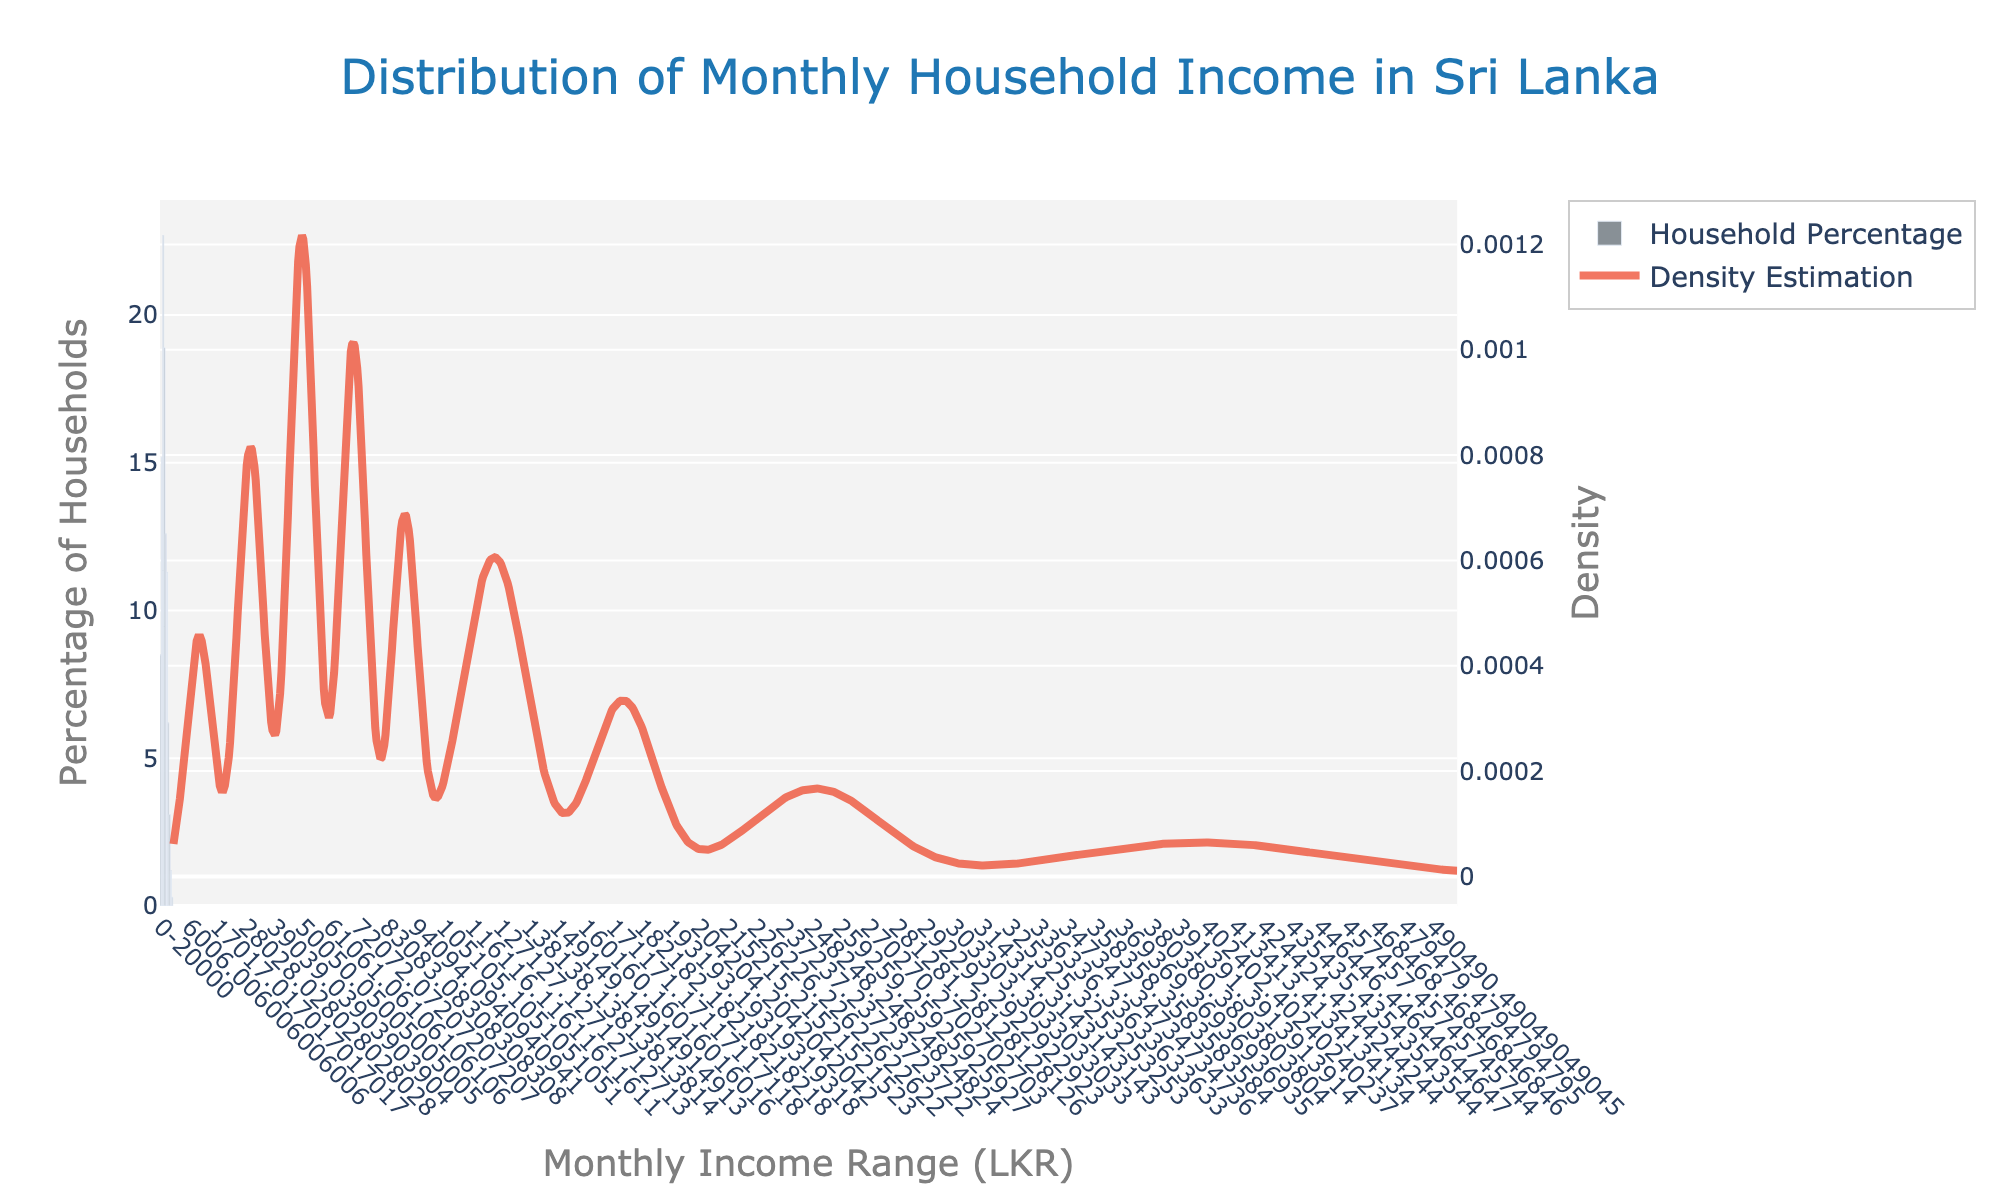What is the title of the figure? The title is located at the top center of the plot and reads "Distribution of Monthly Household Income in Sri Lanka".
Answer: Distribution of Monthly Household Income in Sri Lanka What is the income range with the highest percentage of households? By looking at the height of the bars, the tallest bar is for the income range "40001-60000", which indicates the highest percentage of households.
Answer: 40001-60000 Which income range has the lowest percentage of households, and what is its percentage? The smallest bar corresponds to the "500001+" income range, with a height denoting 0.3%.
Answer: 500001+, 0.3% How does the "100001-150000" income range compare to the "60001-80000" range in terms of household percentage? By comparing the heights of the bars, the "100001-150000" range (11.3%) is lower than the "60001-80000" range (18.9%).
Answer: 100001-150000 is lower than 60001-80000 Between which income ranges is most of the population concentrated? Observing the highest bars, most of the households fall between "20001-40000", "40001-60000", and "60001-80000".
Answer: 20001-80000 What is the shape of the density estimation curve around the "40001-60000" income range? The KDE peak near the "40001-60000" indicates a high density of households within this range, showing a peak in the curve.
Answer: Peak How many income ranges have a household percentage below 10%? Examine the bars below the 10% mark: "0-20000", "150001-200000", "200001-300000", "300001-500000", and "500001+." There are 5 such ranges.
Answer: 5 What is the difference in household percentage between the "40001-60000" and the "20001-40000" income ranges? Subtract the percentage of "20001-40000" (15.2%) from "40001-60000" (22.7%): 22.7% - 15.2% = 7.5%.
Answer: 7.5% Which income range has the highest density according to the KDE curve, and why is this significant? The highest density is around the "40001-60000" range, which suggests most households are in this income bracket.
Answer: 40001-60000, significant because it denotes where most households are concentrated 